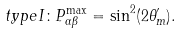<formula> <loc_0><loc_0><loc_500><loc_500>t y p e I \colon P ^ { \max } _ { \alpha \beta } = \sin ^ { 2 } ( 2 \theta ^ { \prime } _ { m } ) .</formula> 